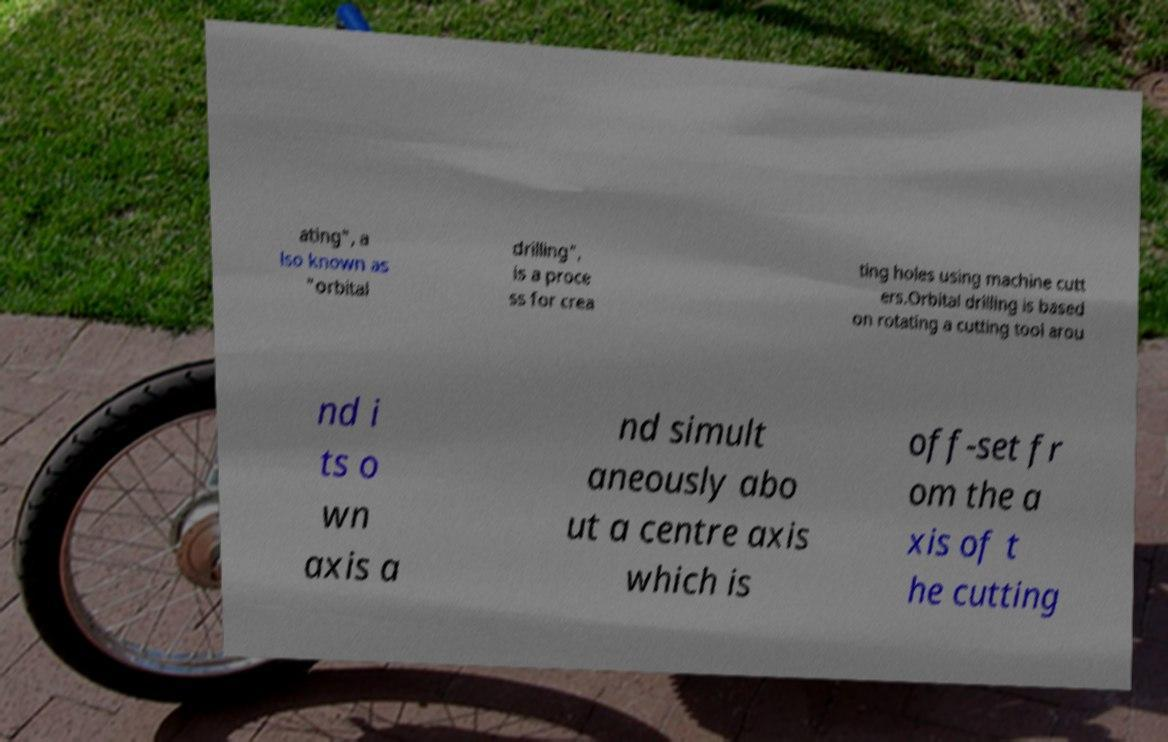Can you accurately transcribe the text from the provided image for me? ating", a lso known as "orbital drilling", is a proce ss for crea ting holes using machine cutt ers.Orbital drilling is based on rotating a cutting tool arou nd i ts o wn axis a nd simult aneously abo ut a centre axis which is off-set fr om the a xis of t he cutting 